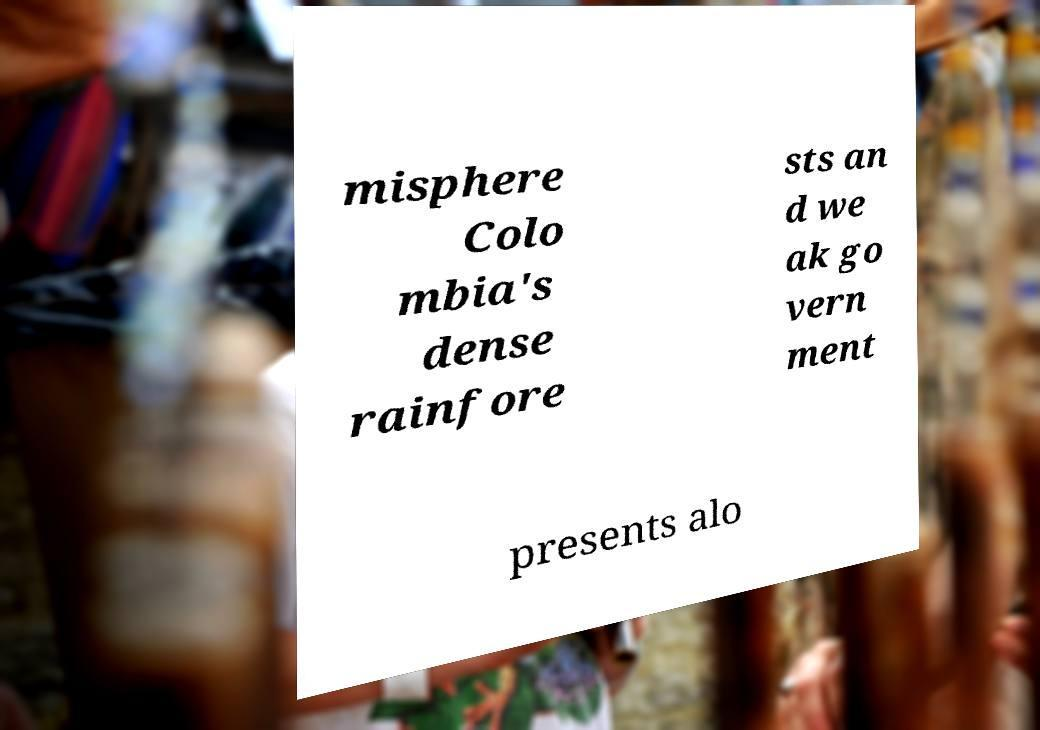What messages or text are displayed in this image? I need them in a readable, typed format. misphere Colo mbia's dense rainfore sts an d we ak go vern ment presents alo 